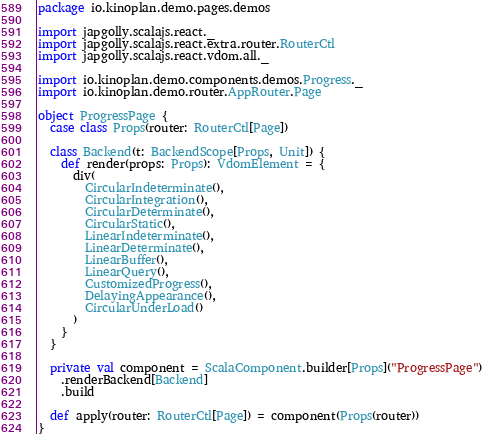<code> <loc_0><loc_0><loc_500><loc_500><_Scala_>package io.kinoplan.demo.pages.demos

import japgolly.scalajs.react._
import japgolly.scalajs.react.extra.router.RouterCtl
import japgolly.scalajs.react.vdom.all._

import io.kinoplan.demo.components.demos.Progress._
import io.kinoplan.demo.router.AppRouter.Page

object ProgressPage {
  case class Props(router: RouterCtl[Page])

  class Backend(t: BackendScope[Props, Unit]) {
    def render(props: Props): VdomElement = {
      div(
        CircularIndeterminate(),
        CircularIntegration(),
        CircularDeterminate(),
        CircularStatic(),
        LinearIndeterminate(),
        LinearDeterminate(),
        LinearBuffer(),
        LinearQuery(),
        CustomizedProgress(),
        DelayingAppearance(),
        CircularUnderLoad()
      )
    }
  }

  private val component = ScalaComponent.builder[Props]("ProgressPage")
    .renderBackend[Backend]
    .build

  def apply(router: RouterCtl[Page]) = component(Props(router))
}
</code> 